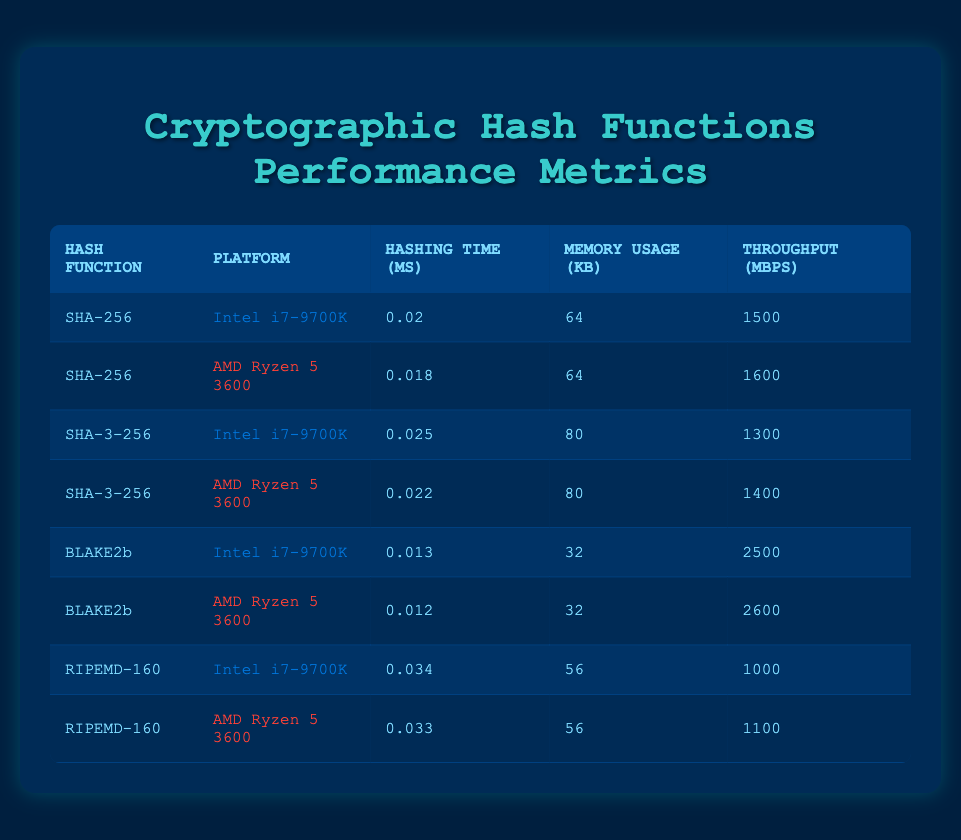What is the hashing time for BLAKE2b on AMD Ryzen 5 3600? The table lists the hashing time for BLAKE2b on the AMD Ryzen 5 3600 as 0.012 ms.
Answer: 0.012 ms Which hash function has the highest throughput on Intel i7-9700K? By comparing the throughput values, BLAKE2b has the highest throughput at 2500 Mbps on Intel i7-9700K, compared to other hash functions.
Answer: BLAKE2b What is the total memory usage for SHA-256 across both platforms? SHA-256 uses 64 kB of memory on both the Intel i7-9700K and AMD Ryzen 5 3600. The total memory usage is 64 + 64 = 128 kB.
Answer: 128 kB Is the hashing time for SHA-3-256 on AMD Ryzen 5 3600 faster than on Intel i7-9700K? The hashing time for SHA-3-256 on AMD Ryzen 5 3600 is 0.022 ms, which is faster than the 0.025 ms on Intel i7-9700K. Therefore, the statement is true.
Answer: Yes What is the average throughput for all hash functions on Intel i7-9700K? The throughput values for Intel i7-9700K are 1500, 1300, 2500, and 1000 Mbps. Summing these gives 1500 + 1300 + 2500 + 1000 = 6300 Mbps. Dividing by the 4 functions gives an average of 6300 / 4 = 1575 Mbps.
Answer: 1575 Mbps Which hash function uses the least amount of memory across both platforms? BLAKE2b on both platforms uses the least amount of memory at 32 kB, which is lower than the other hash functions presented.
Answer: BLAKE2b Is the throughput for RIPEMD-160 on AMD Ryzen 5 3600 higher than 1200 Mbps? The throughput for RIPEMD-160 on AMD Ryzen 5 3600 is 1100 Mbps, which is not higher than 1200 Mbps. Therefore, the statement is false.
Answer: No What is the difference in hashing time between SHA-256 on Intel i7-9700K and BLAKE2b on the same platform? The hashing time for SHA-256 on Intel i7-9700K is 0.020 ms, and for BLAKE2b, it is 0.013 ms. The difference is 0.020 - 0.013 = 0.007 ms.
Answer: 0.007 ms What is the maximum memory usage for any hash function across both platforms? By examining the memory usage values, SHA-3-256 and SHA-256 use 80 kB and 64 kB, respectively, while both BLAKE2b and RIPEMD-160 use 32 kB and 56 kB. The maximum value is 80 kB for SHA-3-256.
Answer: 80 kB 